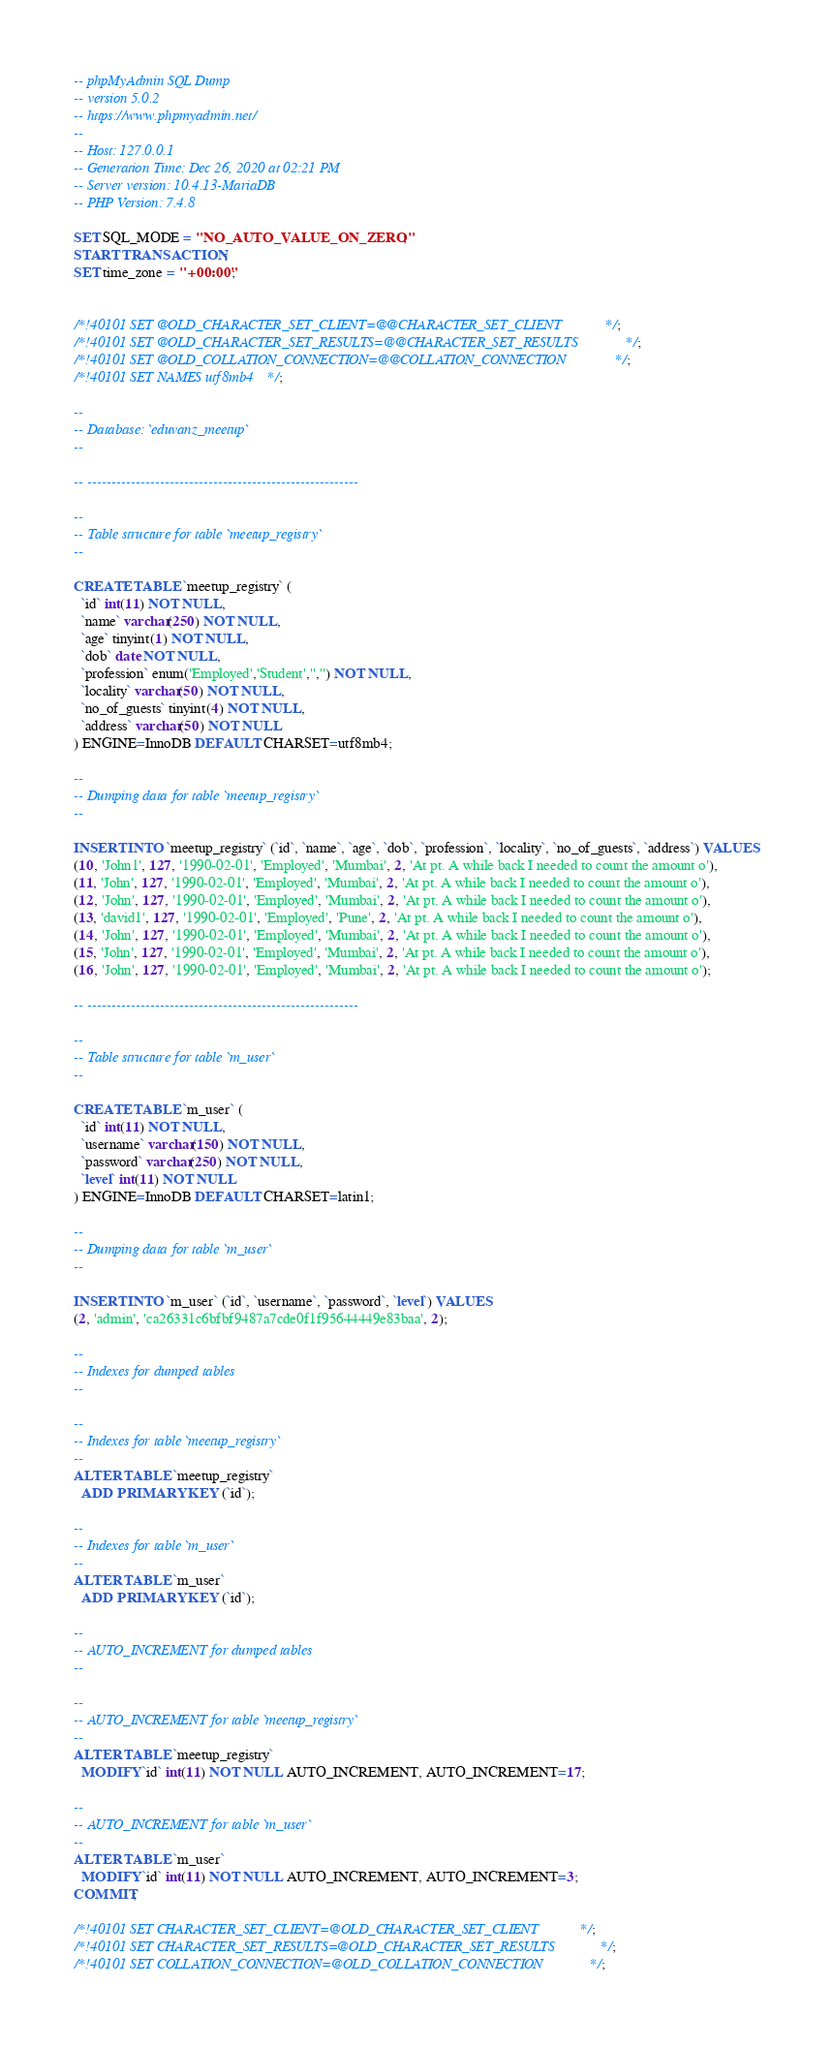<code> <loc_0><loc_0><loc_500><loc_500><_SQL_>-- phpMyAdmin SQL Dump
-- version 5.0.2
-- https://www.phpmyadmin.net/
--
-- Host: 127.0.0.1
-- Generation Time: Dec 26, 2020 at 02:21 PM
-- Server version: 10.4.13-MariaDB
-- PHP Version: 7.4.8

SET SQL_MODE = "NO_AUTO_VALUE_ON_ZERO";
START TRANSACTION;
SET time_zone = "+00:00";


/*!40101 SET @OLD_CHARACTER_SET_CLIENT=@@CHARACTER_SET_CLIENT */;
/*!40101 SET @OLD_CHARACTER_SET_RESULTS=@@CHARACTER_SET_RESULTS */;
/*!40101 SET @OLD_COLLATION_CONNECTION=@@COLLATION_CONNECTION */;
/*!40101 SET NAMES utf8mb4 */;

--
-- Database: `eduvanz_meetup`
--

-- --------------------------------------------------------

--
-- Table structure for table `meetup_registry`
--

CREATE TABLE `meetup_registry` (
  `id` int(11) NOT NULL,
  `name` varchar(250) NOT NULL,
  `age` tinyint(1) NOT NULL,
  `dob` date NOT NULL,
  `profession` enum('Employed','Student','','') NOT NULL,
  `locality` varchar(50) NOT NULL,
  `no_of_guests` tinyint(4) NOT NULL,
  `address` varchar(50) NOT NULL
) ENGINE=InnoDB DEFAULT CHARSET=utf8mb4;

--
-- Dumping data for table `meetup_registry`
--

INSERT INTO `meetup_registry` (`id`, `name`, `age`, `dob`, `profession`, `locality`, `no_of_guests`, `address`) VALUES
(10, 'John1', 127, '1990-02-01', 'Employed', 'Mumbai', 2, 'At pt. A while back I needed to count the amount o'),
(11, 'John', 127, '1990-02-01', 'Employed', 'Mumbai', 2, 'At pt. A while back I needed to count the amount o'),
(12, 'John', 127, '1990-02-01', 'Employed', 'Mumbai', 2, 'At pt. A while back I needed to count the amount o'),
(13, 'david1', 127, '1990-02-01', 'Employed', 'Pune', 2, 'At pt. A while back I needed to count the amount o'),
(14, 'John', 127, '1990-02-01', 'Employed', 'Mumbai', 2, 'At pt. A while back I needed to count the amount o'),
(15, 'John', 127, '1990-02-01', 'Employed', 'Mumbai', 2, 'At pt. A while back I needed to count the amount o'),
(16, 'John', 127, '1990-02-01', 'Employed', 'Mumbai', 2, 'At pt. A while back I needed to count the amount o');

-- --------------------------------------------------------

--
-- Table structure for table `m_user`
--

CREATE TABLE `m_user` (
  `id` int(11) NOT NULL,
  `username` varchar(150) NOT NULL,
  `password` varchar(250) NOT NULL,
  `level` int(11) NOT NULL
) ENGINE=InnoDB DEFAULT CHARSET=latin1;

--
-- Dumping data for table `m_user`
--

INSERT INTO `m_user` (`id`, `username`, `password`, `level`) VALUES
(2, 'admin', 'ca26331c6bfbf9487a7cde0f1f95644449e83baa', 2);

--
-- Indexes for dumped tables
--

--
-- Indexes for table `meetup_registry`
--
ALTER TABLE `meetup_registry`
  ADD PRIMARY KEY (`id`);

--
-- Indexes for table `m_user`
--
ALTER TABLE `m_user`
  ADD PRIMARY KEY (`id`);

--
-- AUTO_INCREMENT for dumped tables
--

--
-- AUTO_INCREMENT for table `meetup_registry`
--
ALTER TABLE `meetup_registry`
  MODIFY `id` int(11) NOT NULL AUTO_INCREMENT, AUTO_INCREMENT=17;

--
-- AUTO_INCREMENT for table `m_user`
--
ALTER TABLE `m_user`
  MODIFY `id` int(11) NOT NULL AUTO_INCREMENT, AUTO_INCREMENT=3;
COMMIT;

/*!40101 SET CHARACTER_SET_CLIENT=@OLD_CHARACTER_SET_CLIENT */;
/*!40101 SET CHARACTER_SET_RESULTS=@OLD_CHARACTER_SET_RESULTS */;
/*!40101 SET COLLATION_CONNECTION=@OLD_COLLATION_CONNECTION */;
</code> 